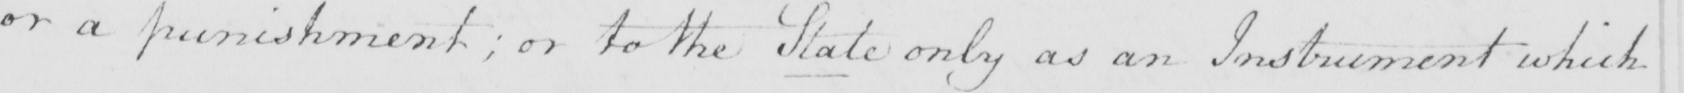What is written in this line of handwriting? or a punishment ; or to the State only as an Instrument which 